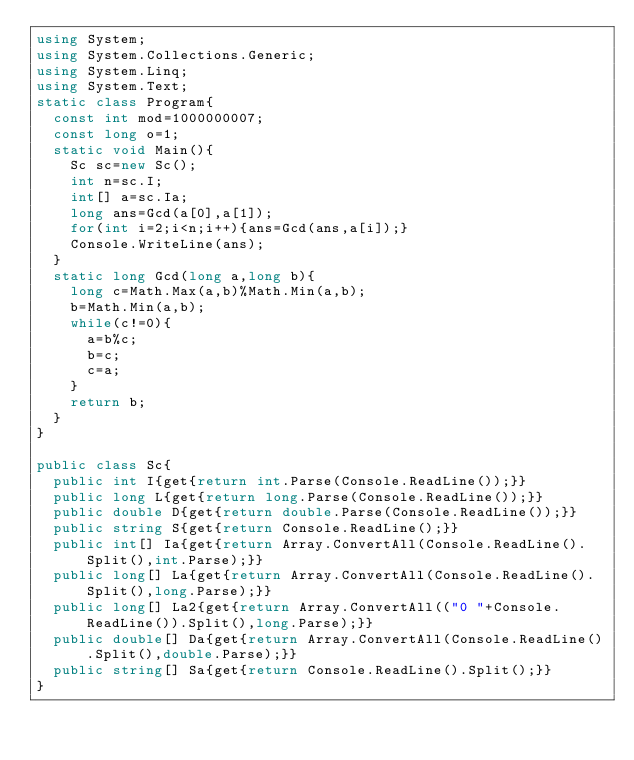<code> <loc_0><loc_0><loc_500><loc_500><_C#_>using System;
using System.Collections.Generic;
using System.Linq;
using System.Text;
static class Program{
	const int mod=1000000007;
	const long o=1;
	static void Main(){
		Sc sc=new Sc();
		int n=sc.I;
		int[] a=sc.Ia;
		long ans=Gcd(a[0],a[1]);
		for(int i=2;i<n;i++){ans=Gcd(ans,a[i]);}
		Console.WriteLine(ans);
	}
	static long Gcd(long a,long b){
		long c=Math.Max(a,b)%Math.Min(a,b);
		b=Math.Min(a,b);
		while(c!=0){
			a=b%c;
			b=c;
			c=a;
		}
		return b;
	}
}

public class Sc{
	public int I{get{return int.Parse(Console.ReadLine());}}
	public long L{get{return long.Parse(Console.ReadLine());}}
	public double D{get{return double.Parse(Console.ReadLine());}}
	public string S{get{return Console.ReadLine();}}
	public int[] Ia{get{return Array.ConvertAll(Console.ReadLine().Split(),int.Parse);}}
	public long[] La{get{return Array.ConvertAll(Console.ReadLine().Split(),long.Parse);}}
	public long[] La2{get{return Array.ConvertAll(("0 "+Console.ReadLine()).Split(),long.Parse);}}
	public double[] Da{get{return Array.ConvertAll(Console.ReadLine().Split(),double.Parse);}}
	public string[] Sa{get{return Console.ReadLine().Split();}}
}</code> 